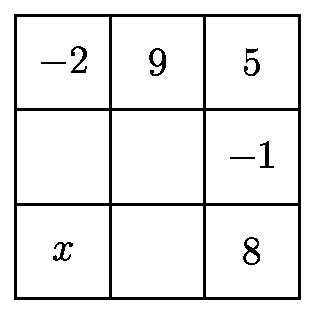Could you explain how to approach solving this puzzle? Certainly! To solve this number grid puzzle, you will need to determine the missing numbers so that the sum of integers in each row and each column is the same. Start by adding the numbers in the rows or columns that have the fewest missing values to find a baseline sum. Then, use this baseline to calculate the missing numbers in other rows and columns, keeping in mind that the number $x$ must be the largest among the missing numbers. 